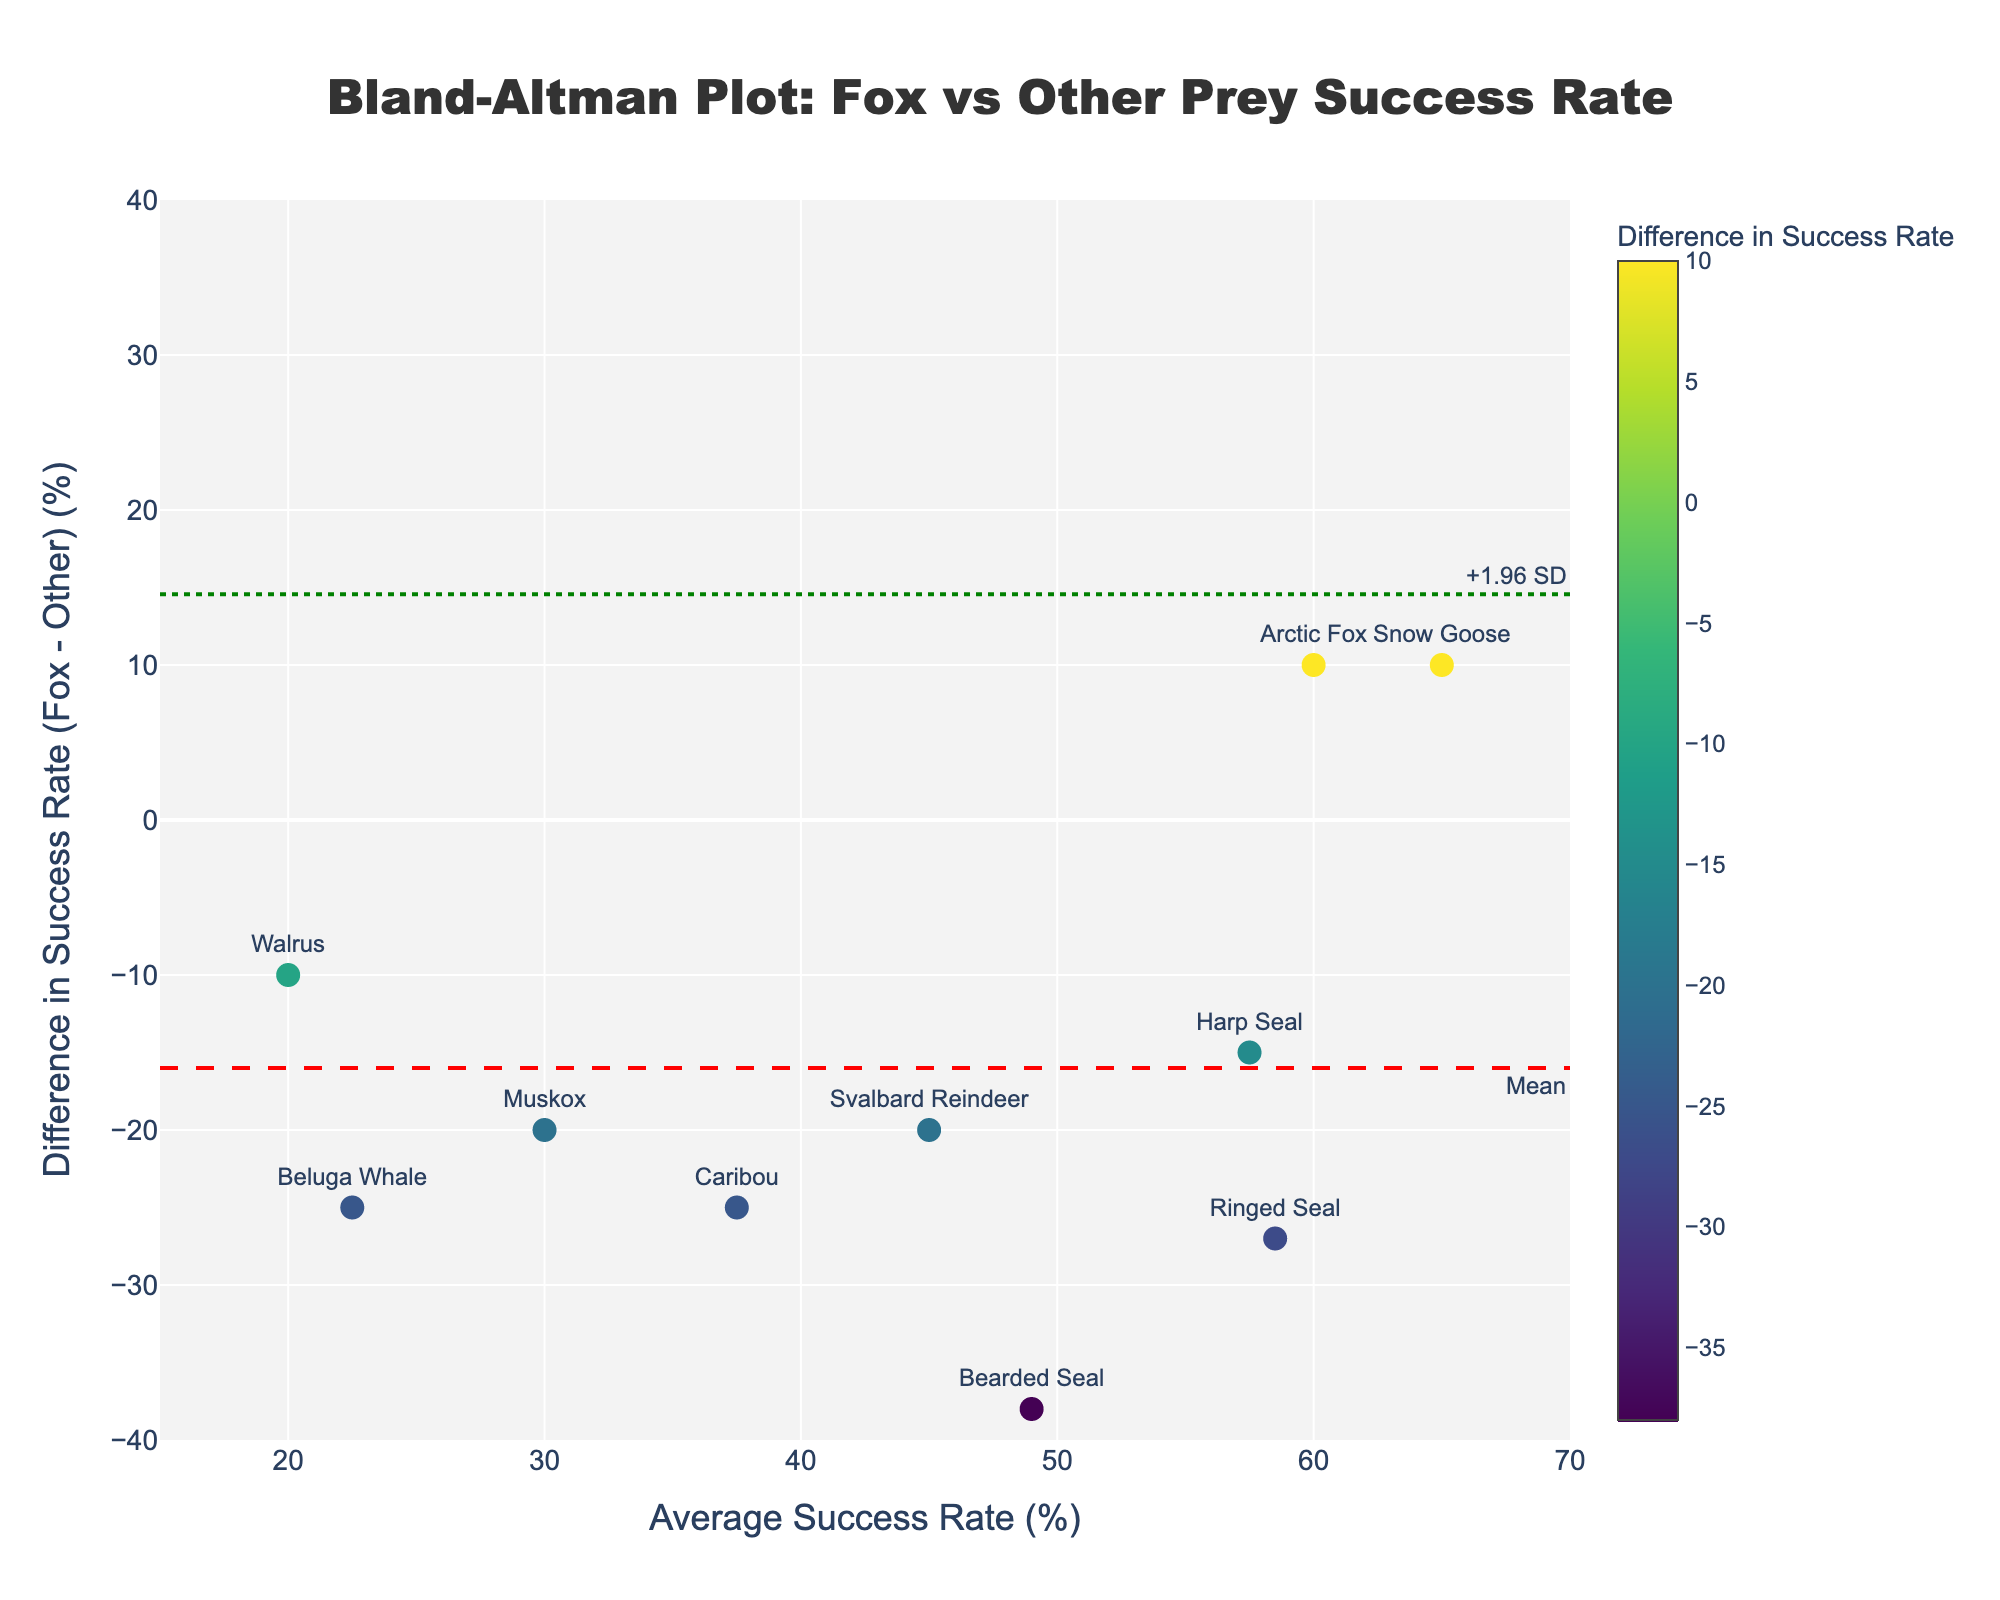What's the title of the plot? The title of the plot is displayed at the top and is clearly visible. It reads "Bland-Altman Plot: Fox vs Other Prey Success Rate".
Answer: Bland-Altman Plot: Fox vs Other Prey Success Rate What is the x-axis title? The x-axis title is located along the bottom axis of the plot and reads "Average Success Rate (%)".
Answer: Average Success Rate (%) How many prey types are plotted in the figure? Each prey type is represented by a unique data point on the plot, and the points can be counted. There are 10 data points on the plot.
Answer: 10 Which prey type has the largest positive difference in success rate between targeting foxes and other prey? Check the point with the highest y-value on the vertical axis of the plot. The text label corresponding to this point is "Snow Goose".
Answer: Snow Goose What is the average success rate for the prey type "Beluga Whale"? Find the data point labeled "Beluga Whale" and note its x-coordinate value, which represents the average success rate. The x-value is 22.5%.
Answer: 22.5% How does the difference in success rates for "Ringed Seal" compare to that for "Harp Seal"? Look at the y-values for both "Ringed Seal" and "Harp Seal". The "Ringed Seal" has a difference represented by the y-value, which is negative, while "Harp Seal" also has a negative difference. The "Harp Seal" has a less negative y-value than the "Ringed Seal".
Answer: "Harp Seal" has a less negative difference What are the boundary values for the lines representing ±1.96 standard deviations? The dashed lines and the dotted green lines represent the mean difference and the ±1.96 SD limits. The mean difference (red line) is around what looks to be, and the ±1.96 SD (green dotted lines) are at -11.1% and -62.9%.
Answer: [-62.9%, -11.1%] What is the color scale title used to indicate the difference in success rates? The color scale is shown on the right side of the plot and is labeled "Difference in Success Rate."
Answer: Difference in Success Rate Which prey type is closest to having zero difference in success rates between targeting foxes and other prey? Find the data point closest to the y=0 line on the plot. The label for this point is "Snow Goose".
Answer: Snow Goose 